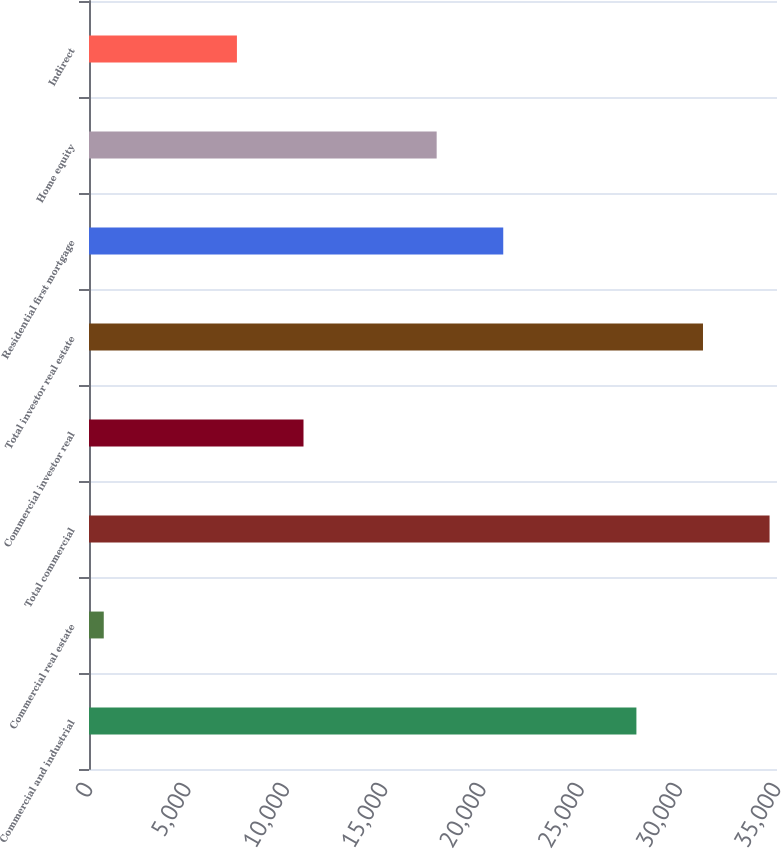Convert chart to OTSL. <chart><loc_0><loc_0><loc_500><loc_500><bar_chart><fcel>Commercial and industrial<fcel>Commercial real estate<fcel>Total commercial<fcel>Commercial investor real<fcel>Total investor real estate<fcel>Residential first mortgage<fcel>Home equity<fcel>Indirect<nl><fcel>27847.8<fcel>751<fcel>34622<fcel>10912.3<fcel>31234.9<fcel>21073.6<fcel>17686.5<fcel>7525.2<nl></chart> 